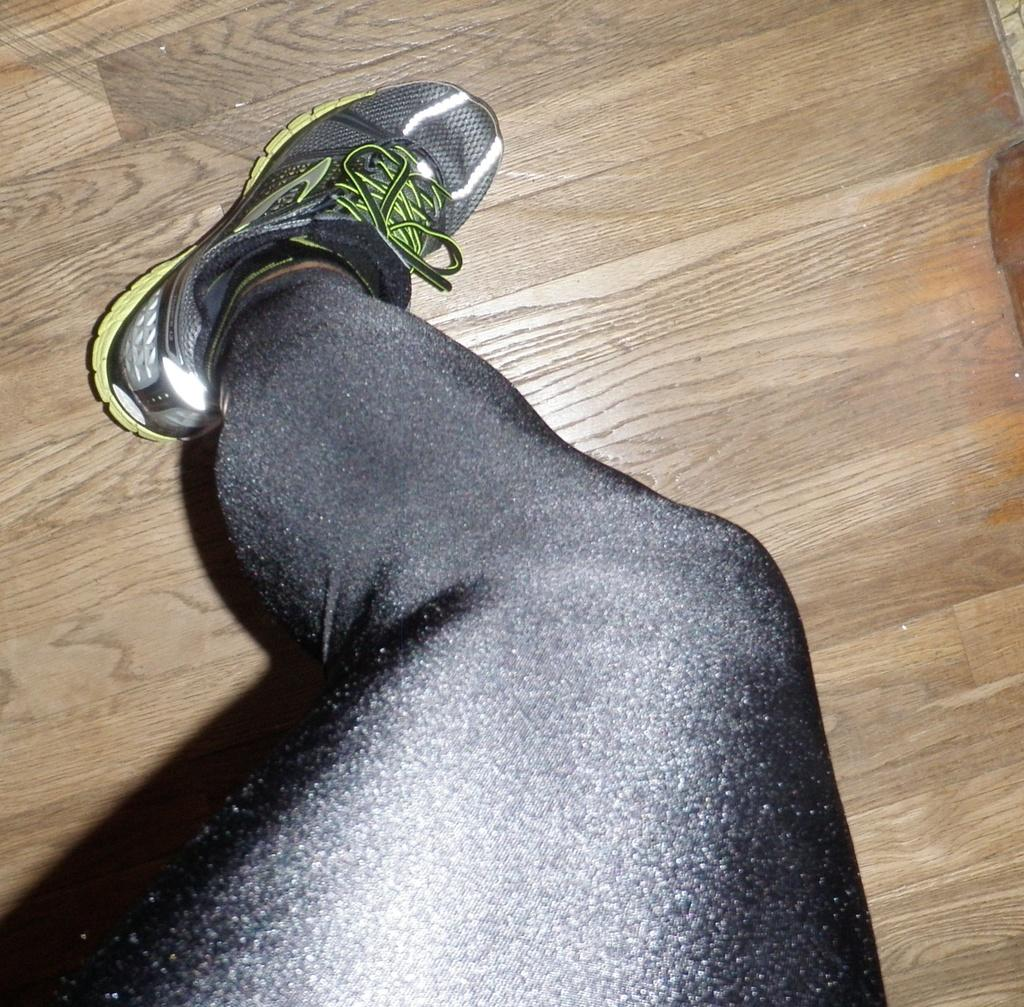What part of a person can be seen in the image? There is a leg of a person in the image. What type of surface is the leg resting on? The leg is on a wooden surface. What is the name of the person whose leg is visible in the image? The provided facts do not include any information about the person's name, so it cannot be determined from the image. 